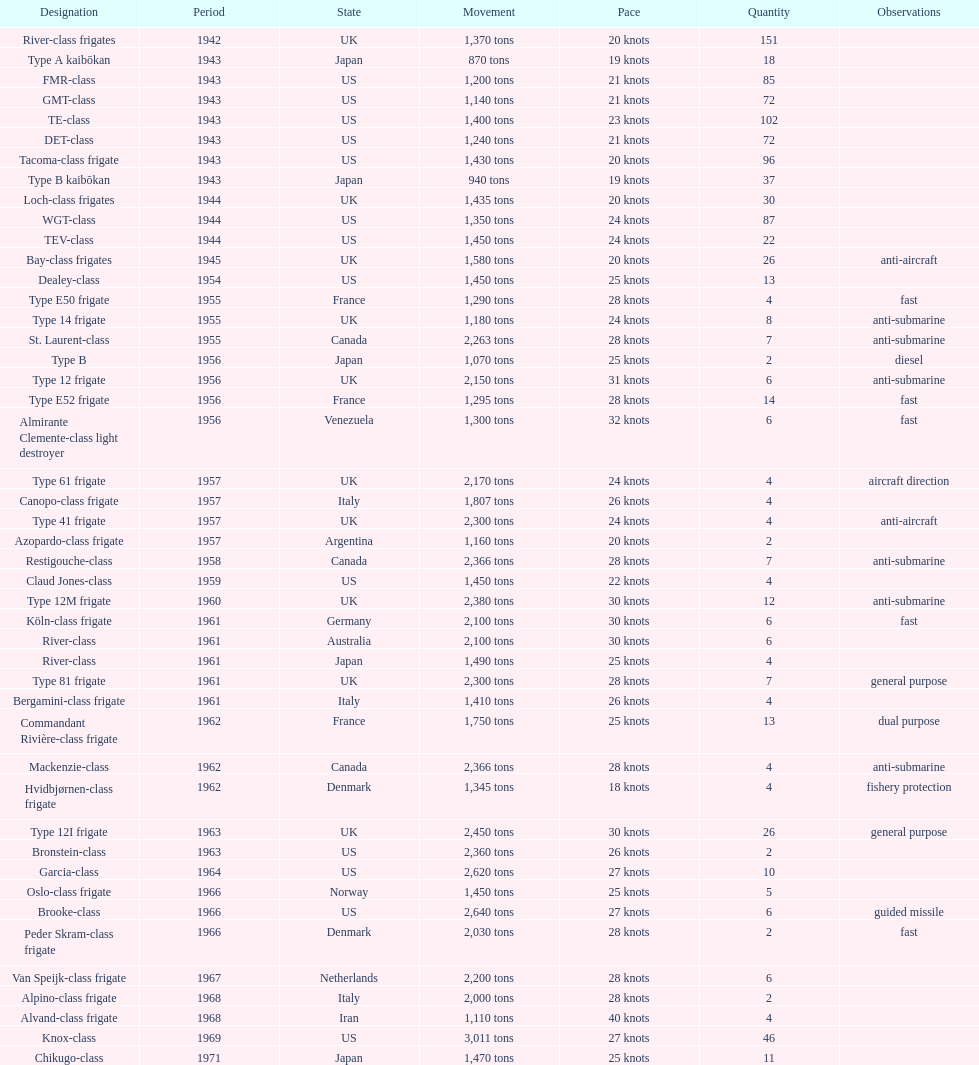How many tons of displacement does type b have? 940 tons. 